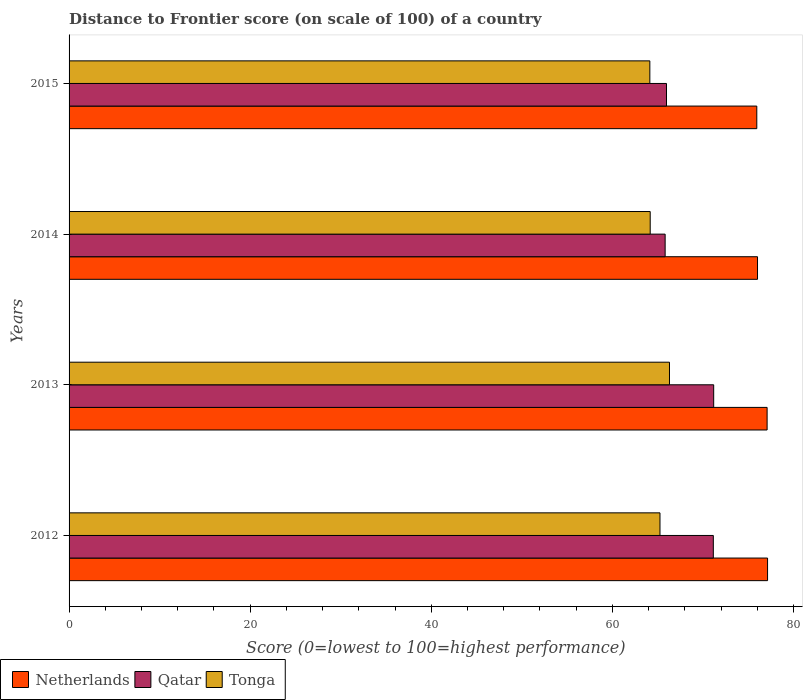How many different coloured bars are there?
Ensure brevity in your answer.  3. Are the number of bars per tick equal to the number of legend labels?
Offer a terse response. Yes. How many bars are there on the 2nd tick from the bottom?
Your response must be concise. 3. What is the distance to frontier score of in Tonga in 2015?
Make the answer very short. 64.13. Across all years, what is the maximum distance to frontier score of in Qatar?
Provide a short and direct response. 71.18. Across all years, what is the minimum distance to frontier score of in Tonga?
Offer a terse response. 64.13. In which year was the distance to frontier score of in Netherlands minimum?
Offer a very short reply. 2015. What is the total distance to frontier score of in Netherlands in the graph?
Your answer should be very brief. 306.17. What is the difference between the distance to frontier score of in Tonga in 2014 and that in 2015?
Keep it short and to the point. 0.04. What is the difference between the distance to frontier score of in Qatar in 2014 and the distance to frontier score of in Netherlands in 2013?
Your answer should be very brief. -11.26. What is the average distance to frontier score of in Netherlands per year?
Offer a very short reply. 76.54. In the year 2012, what is the difference between the distance to frontier score of in Netherlands and distance to frontier score of in Qatar?
Ensure brevity in your answer.  5.99. What is the ratio of the distance to frontier score of in Tonga in 2013 to that in 2015?
Make the answer very short. 1.03. Is the difference between the distance to frontier score of in Netherlands in 2013 and 2014 greater than the difference between the distance to frontier score of in Qatar in 2013 and 2014?
Keep it short and to the point. No. What is the difference between the highest and the second highest distance to frontier score of in Qatar?
Keep it short and to the point. 0.04. What is the difference between the highest and the lowest distance to frontier score of in Tonga?
Offer a very short reply. 2.17. In how many years, is the distance to frontier score of in Qatar greater than the average distance to frontier score of in Qatar taken over all years?
Offer a very short reply. 2. Is the sum of the distance to frontier score of in Qatar in 2013 and 2015 greater than the maximum distance to frontier score of in Netherlands across all years?
Ensure brevity in your answer.  Yes. What does the 2nd bar from the top in 2012 represents?
Your answer should be compact. Qatar. Is it the case that in every year, the sum of the distance to frontier score of in Qatar and distance to frontier score of in Tonga is greater than the distance to frontier score of in Netherlands?
Offer a very short reply. Yes. How many bars are there?
Give a very brief answer. 12. What is the difference between two consecutive major ticks on the X-axis?
Your response must be concise. 20. Are the values on the major ticks of X-axis written in scientific E-notation?
Make the answer very short. No. How many legend labels are there?
Your answer should be very brief. 3. What is the title of the graph?
Offer a very short reply. Distance to Frontier score (on scale of 100) of a country. What is the label or title of the X-axis?
Your answer should be very brief. Score (0=lowest to 100=highest performance). What is the Score (0=lowest to 100=highest performance) of Netherlands in 2012?
Provide a short and direct response. 77.13. What is the Score (0=lowest to 100=highest performance) of Qatar in 2012?
Your answer should be compact. 71.14. What is the Score (0=lowest to 100=highest performance) in Tonga in 2012?
Give a very brief answer. 65.25. What is the Score (0=lowest to 100=highest performance) in Netherlands in 2013?
Your response must be concise. 77.08. What is the Score (0=lowest to 100=highest performance) of Qatar in 2013?
Make the answer very short. 71.18. What is the Score (0=lowest to 100=highest performance) in Tonga in 2013?
Provide a short and direct response. 66.3. What is the Score (0=lowest to 100=highest performance) in Netherlands in 2014?
Your response must be concise. 76.02. What is the Score (0=lowest to 100=highest performance) in Qatar in 2014?
Provide a short and direct response. 65.82. What is the Score (0=lowest to 100=highest performance) of Tonga in 2014?
Offer a terse response. 64.17. What is the Score (0=lowest to 100=highest performance) in Netherlands in 2015?
Offer a very short reply. 75.94. What is the Score (0=lowest to 100=highest performance) in Qatar in 2015?
Your answer should be very brief. 65.97. What is the Score (0=lowest to 100=highest performance) of Tonga in 2015?
Give a very brief answer. 64.13. Across all years, what is the maximum Score (0=lowest to 100=highest performance) of Netherlands?
Your answer should be very brief. 77.13. Across all years, what is the maximum Score (0=lowest to 100=highest performance) of Qatar?
Provide a succinct answer. 71.18. Across all years, what is the maximum Score (0=lowest to 100=highest performance) of Tonga?
Your response must be concise. 66.3. Across all years, what is the minimum Score (0=lowest to 100=highest performance) of Netherlands?
Make the answer very short. 75.94. Across all years, what is the minimum Score (0=lowest to 100=highest performance) in Qatar?
Your response must be concise. 65.82. Across all years, what is the minimum Score (0=lowest to 100=highest performance) of Tonga?
Offer a very short reply. 64.13. What is the total Score (0=lowest to 100=highest performance) in Netherlands in the graph?
Offer a very short reply. 306.17. What is the total Score (0=lowest to 100=highest performance) in Qatar in the graph?
Provide a succinct answer. 274.11. What is the total Score (0=lowest to 100=highest performance) of Tonga in the graph?
Provide a short and direct response. 259.85. What is the difference between the Score (0=lowest to 100=highest performance) of Netherlands in 2012 and that in 2013?
Your answer should be compact. 0.05. What is the difference between the Score (0=lowest to 100=highest performance) in Qatar in 2012 and that in 2013?
Make the answer very short. -0.04. What is the difference between the Score (0=lowest to 100=highest performance) of Tonga in 2012 and that in 2013?
Give a very brief answer. -1.05. What is the difference between the Score (0=lowest to 100=highest performance) of Netherlands in 2012 and that in 2014?
Make the answer very short. 1.11. What is the difference between the Score (0=lowest to 100=highest performance) of Qatar in 2012 and that in 2014?
Give a very brief answer. 5.32. What is the difference between the Score (0=lowest to 100=highest performance) in Netherlands in 2012 and that in 2015?
Make the answer very short. 1.19. What is the difference between the Score (0=lowest to 100=highest performance) in Qatar in 2012 and that in 2015?
Offer a terse response. 5.17. What is the difference between the Score (0=lowest to 100=highest performance) in Tonga in 2012 and that in 2015?
Offer a terse response. 1.12. What is the difference between the Score (0=lowest to 100=highest performance) of Netherlands in 2013 and that in 2014?
Your answer should be very brief. 1.06. What is the difference between the Score (0=lowest to 100=highest performance) in Qatar in 2013 and that in 2014?
Your answer should be compact. 5.36. What is the difference between the Score (0=lowest to 100=highest performance) in Tonga in 2013 and that in 2014?
Give a very brief answer. 2.13. What is the difference between the Score (0=lowest to 100=highest performance) in Netherlands in 2013 and that in 2015?
Offer a very short reply. 1.14. What is the difference between the Score (0=lowest to 100=highest performance) of Qatar in 2013 and that in 2015?
Your answer should be compact. 5.21. What is the difference between the Score (0=lowest to 100=highest performance) of Tonga in 2013 and that in 2015?
Your answer should be very brief. 2.17. What is the difference between the Score (0=lowest to 100=highest performance) of Netherlands in 2014 and that in 2015?
Your answer should be very brief. 0.08. What is the difference between the Score (0=lowest to 100=highest performance) of Tonga in 2014 and that in 2015?
Your answer should be compact. 0.04. What is the difference between the Score (0=lowest to 100=highest performance) of Netherlands in 2012 and the Score (0=lowest to 100=highest performance) of Qatar in 2013?
Offer a terse response. 5.95. What is the difference between the Score (0=lowest to 100=highest performance) of Netherlands in 2012 and the Score (0=lowest to 100=highest performance) of Tonga in 2013?
Offer a very short reply. 10.83. What is the difference between the Score (0=lowest to 100=highest performance) in Qatar in 2012 and the Score (0=lowest to 100=highest performance) in Tonga in 2013?
Offer a very short reply. 4.84. What is the difference between the Score (0=lowest to 100=highest performance) of Netherlands in 2012 and the Score (0=lowest to 100=highest performance) of Qatar in 2014?
Your response must be concise. 11.31. What is the difference between the Score (0=lowest to 100=highest performance) in Netherlands in 2012 and the Score (0=lowest to 100=highest performance) in Tonga in 2014?
Provide a short and direct response. 12.96. What is the difference between the Score (0=lowest to 100=highest performance) of Qatar in 2012 and the Score (0=lowest to 100=highest performance) of Tonga in 2014?
Ensure brevity in your answer.  6.97. What is the difference between the Score (0=lowest to 100=highest performance) in Netherlands in 2012 and the Score (0=lowest to 100=highest performance) in Qatar in 2015?
Your answer should be compact. 11.16. What is the difference between the Score (0=lowest to 100=highest performance) in Qatar in 2012 and the Score (0=lowest to 100=highest performance) in Tonga in 2015?
Give a very brief answer. 7.01. What is the difference between the Score (0=lowest to 100=highest performance) in Netherlands in 2013 and the Score (0=lowest to 100=highest performance) in Qatar in 2014?
Offer a terse response. 11.26. What is the difference between the Score (0=lowest to 100=highest performance) in Netherlands in 2013 and the Score (0=lowest to 100=highest performance) in Tonga in 2014?
Keep it short and to the point. 12.91. What is the difference between the Score (0=lowest to 100=highest performance) of Qatar in 2013 and the Score (0=lowest to 100=highest performance) of Tonga in 2014?
Your response must be concise. 7.01. What is the difference between the Score (0=lowest to 100=highest performance) of Netherlands in 2013 and the Score (0=lowest to 100=highest performance) of Qatar in 2015?
Ensure brevity in your answer.  11.11. What is the difference between the Score (0=lowest to 100=highest performance) in Netherlands in 2013 and the Score (0=lowest to 100=highest performance) in Tonga in 2015?
Offer a very short reply. 12.95. What is the difference between the Score (0=lowest to 100=highest performance) in Qatar in 2013 and the Score (0=lowest to 100=highest performance) in Tonga in 2015?
Provide a short and direct response. 7.05. What is the difference between the Score (0=lowest to 100=highest performance) in Netherlands in 2014 and the Score (0=lowest to 100=highest performance) in Qatar in 2015?
Provide a short and direct response. 10.05. What is the difference between the Score (0=lowest to 100=highest performance) in Netherlands in 2014 and the Score (0=lowest to 100=highest performance) in Tonga in 2015?
Provide a short and direct response. 11.89. What is the difference between the Score (0=lowest to 100=highest performance) in Qatar in 2014 and the Score (0=lowest to 100=highest performance) in Tonga in 2015?
Your response must be concise. 1.69. What is the average Score (0=lowest to 100=highest performance) in Netherlands per year?
Ensure brevity in your answer.  76.54. What is the average Score (0=lowest to 100=highest performance) in Qatar per year?
Provide a succinct answer. 68.53. What is the average Score (0=lowest to 100=highest performance) in Tonga per year?
Your answer should be very brief. 64.96. In the year 2012, what is the difference between the Score (0=lowest to 100=highest performance) in Netherlands and Score (0=lowest to 100=highest performance) in Qatar?
Provide a succinct answer. 5.99. In the year 2012, what is the difference between the Score (0=lowest to 100=highest performance) of Netherlands and Score (0=lowest to 100=highest performance) of Tonga?
Offer a terse response. 11.88. In the year 2012, what is the difference between the Score (0=lowest to 100=highest performance) in Qatar and Score (0=lowest to 100=highest performance) in Tonga?
Keep it short and to the point. 5.89. In the year 2013, what is the difference between the Score (0=lowest to 100=highest performance) of Netherlands and Score (0=lowest to 100=highest performance) of Qatar?
Provide a short and direct response. 5.9. In the year 2013, what is the difference between the Score (0=lowest to 100=highest performance) of Netherlands and Score (0=lowest to 100=highest performance) of Tonga?
Offer a terse response. 10.78. In the year 2013, what is the difference between the Score (0=lowest to 100=highest performance) of Qatar and Score (0=lowest to 100=highest performance) of Tonga?
Keep it short and to the point. 4.88. In the year 2014, what is the difference between the Score (0=lowest to 100=highest performance) in Netherlands and Score (0=lowest to 100=highest performance) in Tonga?
Provide a short and direct response. 11.85. In the year 2014, what is the difference between the Score (0=lowest to 100=highest performance) of Qatar and Score (0=lowest to 100=highest performance) of Tonga?
Make the answer very short. 1.65. In the year 2015, what is the difference between the Score (0=lowest to 100=highest performance) of Netherlands and Score (0=lowest to 100=highest performance) of Qatar?
Offer a terse response. 9.97. In the year 2015, what is the difference between the Score (0=lowest to 100=highest performance) of Netherlands and Score (0=lowest to 100=highest performance) of Tonga?
Give a very brief answer. 11.81. In the year 2015, what is the difference between the Score (0=lowest to 100=highest performance) of Qatar and Score (0=lowest to 100=highest performance) of Tonga?
Provide a succinct answer. 1.84. What is the ratio of the Score (0=lowest to 100=highest performance) in Tonga in 2012 to that in 2013?
Give a very brief answer. 0.98. What is the ratio of the Score (0=lowest to 100=highest performance) in Netherlands in 2012 to that in 2014?
Ensure brevity in your answer.  1.01. What is the ratio of the Score (0=lowest to 100=highest performance) of Qatar in 2012 to that in 2014?
Provide a short and direct response. 1.08. What is the ratio of the Score (0=lowest to 100=highest performance) of Tonga in 2012 to that in 2014?
Your answer should be compact. 1.02. What is the ratio of the Score (0=lowest to 100=highest performance) in Netherlands in 2012 to that in 2015?
Offer a very short reply. 1.02. What is the ratio of the Score (0=lowest to 100=highest performance) in Qatar in 2012 to that in 2015?
Your response must be concise. 1.08. What is the ratio of the Score (0=lowest to 100=highest performance) in Tonga in 2012 to that in 2015?
Provide a short and direct response. 1.02. What is the ratio of the Score (0=lowest to 100=highest performance) of Netherlands in 2013 to that in 2014?
Ensure brevity in your answer.  1.01. What is the ratio of the Score (0=lowest to 100=highest performance) of Qatar in 2013 to that in 2014?
Ensure brevity in your answer.  1.08. What is the ratio of the Score (0=lowest to 100=highest performance) in Tonga in 2013 to that in 2014?
Offer a very short reply. 1.03. What is the ratio of the Score (0=lowest to 100=highest performance) in Qatar in 2013 to that in 2015?
Make the answer very short. 1.08. What is the ratio of the Score (0=lowest to 100=highest performance) of Tonga in 2013 to that in 2015?
Your answer should be compact. 1.03. What is the difference between the highest and the second highest Score (0=lowest to 100=highest performance) of Netherlands?
Offer a very short reply. 0.05. What is the difference between the highest and the second highest Score (0=lowest to 100=highest performance) of Qatar?
Provide a succinct answer. 0.04. What is the difference between the highest and the lowest Score (0=lowest to 100=highest performance) of Netherlands?
Your answer should be very brief. 1.19. What is the difference between the highest and the lowest Score (0=lowest to 100=highest performance) of Qatar?
Make the answer very short. 5.36. What is the difference between the highest and the lowest Score (0=lowest to 100=highest performance) in Tonga?
Your response must be concise. 2.17. 